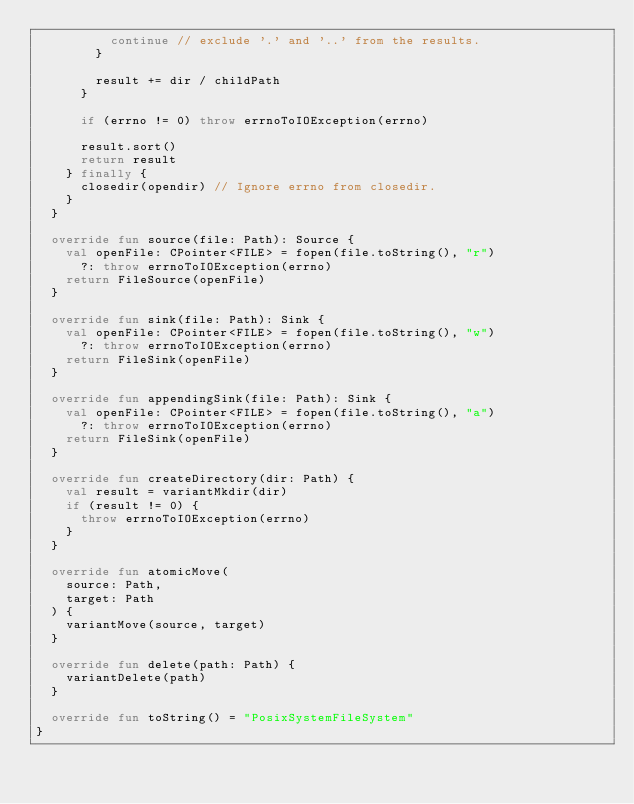<code> <loc_0><loc_0><loc_500><loc_500><_Kotlin_>          continue // exclude '.' and '..' from the results.
        }

        result += dir / childPath
      }

      if (errno != 0) throw errnoToIOException(errno)

      result.sort()
      return result
    } finally {
      closedir(opendir) // Ignore errno from closedir.
    }
  }

  override fun source(file: Path): Source {
    val openFile: CPointer<FILE> = fopen(file.toString(), "r")
      ?: throw errnoToIOException(errno)
    return FileSource(openFile)
  }

  override fun sink(file: Path): Sink {
    val openFile: CPointer<FILE> = fopen(file.toString(), "w")
      ?: throw errnoToIOException(errno)
    return FileSink(openFile)
  }

  override fun appendingSink(file: Path): Sink {
    val openFile: CPointer<FILE> = fopen(file.toString(), "a")
      ?: throw errnoToIOException(errno)
    return FileSink(openFile)
  }

  override fun createDirectory(dir: Path) {
    val result = variantMkdir(dir)
    if (result != 0) {
      throw errnoToIOException(errno)
    }
  }

  override fun atomicMove(
    source: Path,
    target: Path
  ) {
    variantMove(source, target)
  }

  override fun delete(path: Path) {
    variantDelete(path)
  }

  override fun toString() = "PosixSystemFileSystem"
}
</code> 